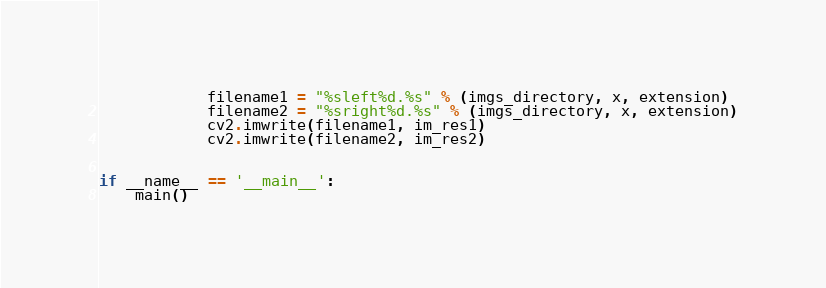<code> <loc_0><loc_0><loc_500><loc_500><_Python_>            filename1 = "%sleft%d.%s" % (imgs_directory, x, extension)
            filename2 = "%sright%d.%s" % (imgs_directory, x, extension)
            cv2.imwrite(filename1, im_res1)
            cv2.imwrite(filename2, im_res2)


if __name__ == '__main__':
    main()

</code> 